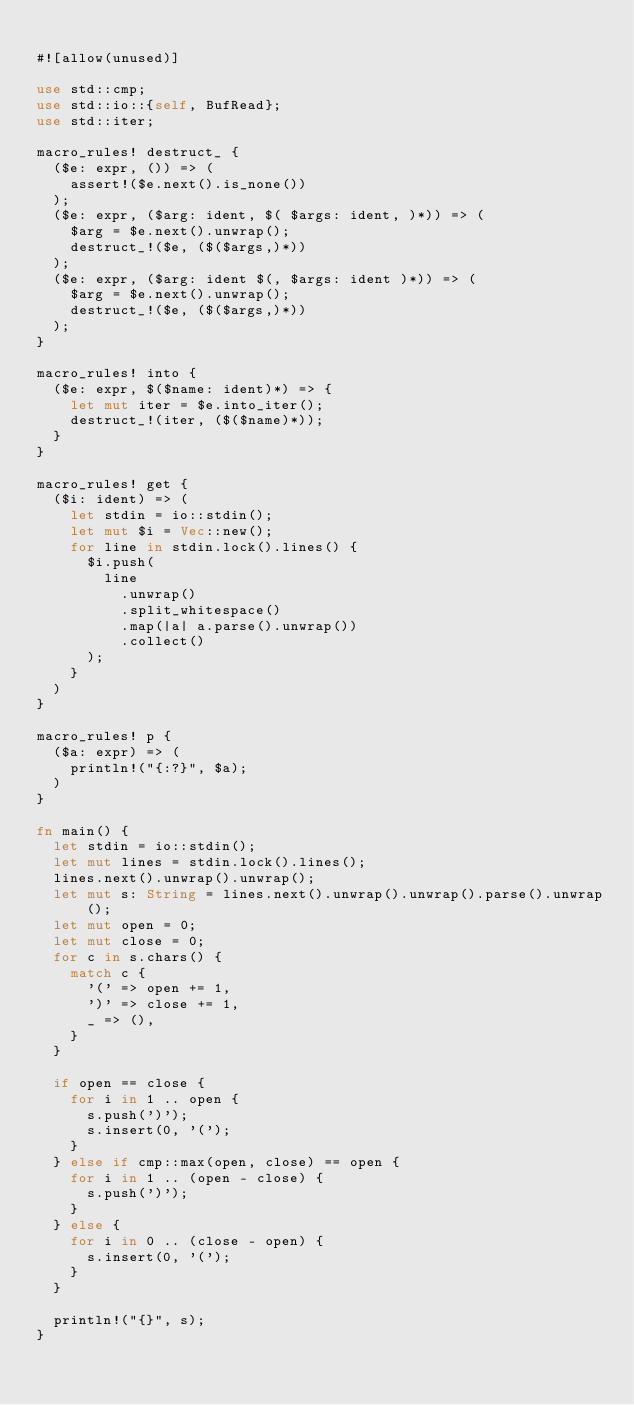<code> <loc_0><loc_0><loc_500><loc_500><_Rust_>
#![allow(unused)]

use std::cmp;
use std::io::{self, BufRead};
use std::iter;

macro_rules! destruct_ {
  ($e: expr, ()) => (
    assert!($e.next().is_none())
  );
  ($e: expr, ($arg: ident, $( $args: ident, )*)) => (
    $arg = $e.next().unwrap();
    destruct_!($e, ($($args,)*))
  );
  ($e: expr, ($arg: ident $(, $args: ident )*)) => (
    $arg = $e.next().unwrap();
    destruct_!($e, ($($args,)*))
  );
}

macro_rules! into {
  ($e: expr, $($name: ident)*) => {
    let mut iter = $e.into_iter();
    destruct_!(iter, ($($name)*));
  }
}

macro_rules! get {
  ($i: ident) => (
    let stdin = io::stdin();
    let mut $i = Vec::new();
    for line in stdin.lock().lines() {
      $i.push(
        line
          .unwrap()
          .split_whitespace()
          .map(|a| a.parse().unwrap())
          .collect()
      );
    }
  )
}

macro_rules! p {
  ($a: expr) => (
    println!("{:?}", $a);
  )
}

fn main() {
  let stdin = io::stdin();
  let mut lines = stdin.lock().lines();
  lines.next().unwrap().unwrap();
  let mut s: String = lines.next().unwrap().unwrap().parse().unwrap();
  let mut open = 0;
  let mut close = 0;
  for c in s.chars() {
    match c {
      '(' => open += 1,
      ')' => close += 1,
      _ => (),
    }
  }

  if open == close {
    for i in 1 .. open {
      s.push(')');
      s.insert(0, '(');
    }
  } else if cmp::max(open, close) == open {
    for i in 1 .. (open - close) {
      s.push(')');
    }
  } else {
    for i in 0 .. (close - open) {
      s.insert(0, '(');
    }
  }

  println!("{}", s);
}
</code> 